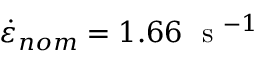<formula> <loc_0><loc_0><loc_500><loc_500>\dot { \varepsilon } _ { n o m } = 1 . 6 6 s ^ { - 1 }</formula> 